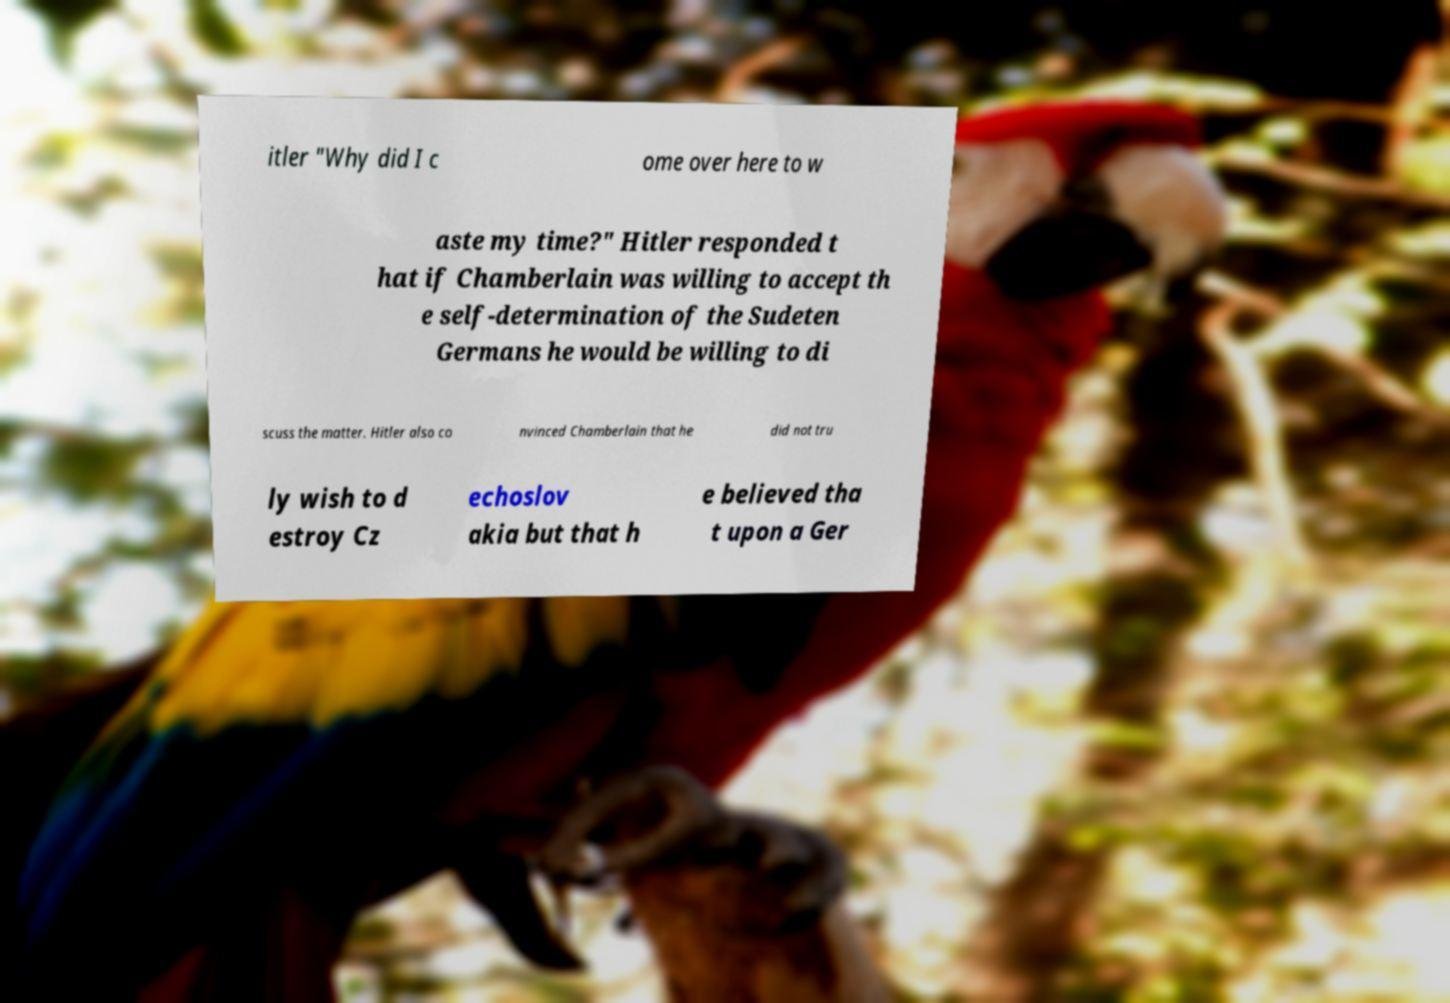What messages or text are displayed in this image? I need them in a readable, typed format. itler "Why did I c ome over here to w aste my time?" Hitler responded t hat if Chamberlain was willing to accept th e self-determination of the Sudeten Germans he would be willing to di scuss the matter. Hitler also co nvinced Chamberlain that he did not tru ly wish to d estroy Cz echoslov akia but that h e believed tha t upon a Ger 